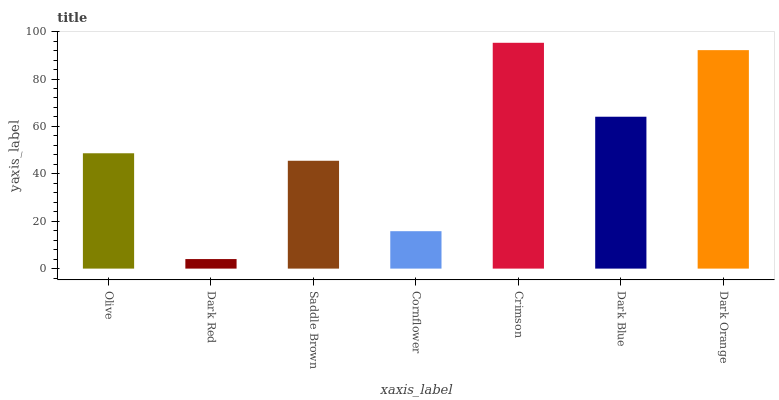Is Dark Red the minimum?
Answer yes or no. Yes. Is Crimson the maximum?
Answer yes or no. Yes. Is Saddle Brown the minimum?
Answer yes or no. No. Is Saddle Brown the maximum?
Answer yes or no. No. Is Saddle Brown greater than Dark Red?
Answer yes or no. Yes. Is Dark Red less than Saddle Brown?
Answer yes or no. Yes. Is Dark Red greater than Saddle Brown?
Answer yes or no. No. Is Saddle Brown less than Dark Red?
Answer yes or no. No. Is Olive the high median?
Answer yes or no. Yes. Is Olive the low median?
Answer yes or no. Yes. Is Cornflower the high median?
Answer yes or no. No. Is Saddle Brown the low median?
Answer yes or no. No. 